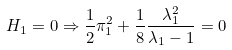<formula> <loc_0><loc_0><loc_500><loc_500>H _ { 1 } = 0 \Rightarrow \frac { 1 } { 2 } \pi _ { 1 } ^ { 2 } + \frac { 1 } { 8 } \frac { \lambda _ { 1 } ^ { 2 } } { \lambda _ { 1 } - 1 } = 0</formula> 